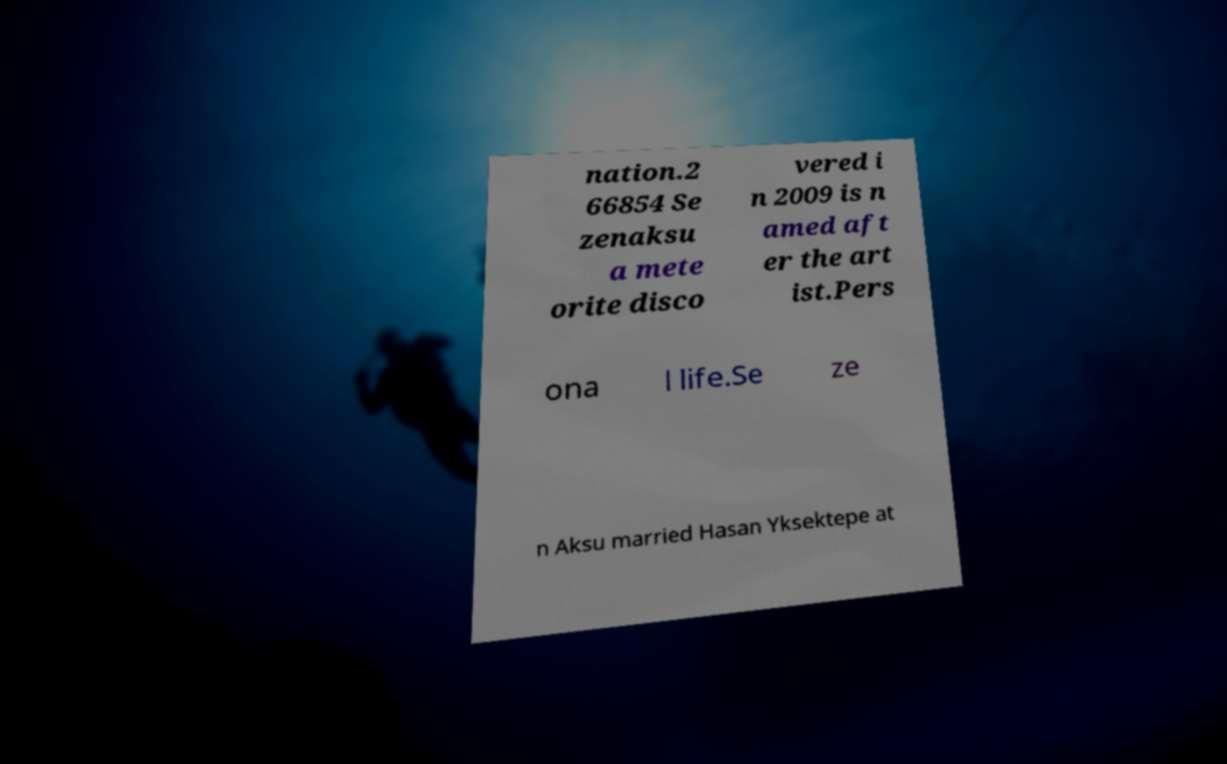There's text embedded in this image that I need extracted. Can you transcribe it verbatim? nation.2 66854 Se zenaksu a mete orite disco vered i n 2009 is n amed aft er the art ist.Pers ona l life.Se ze n Aksu married Hasan Yksektepe at 